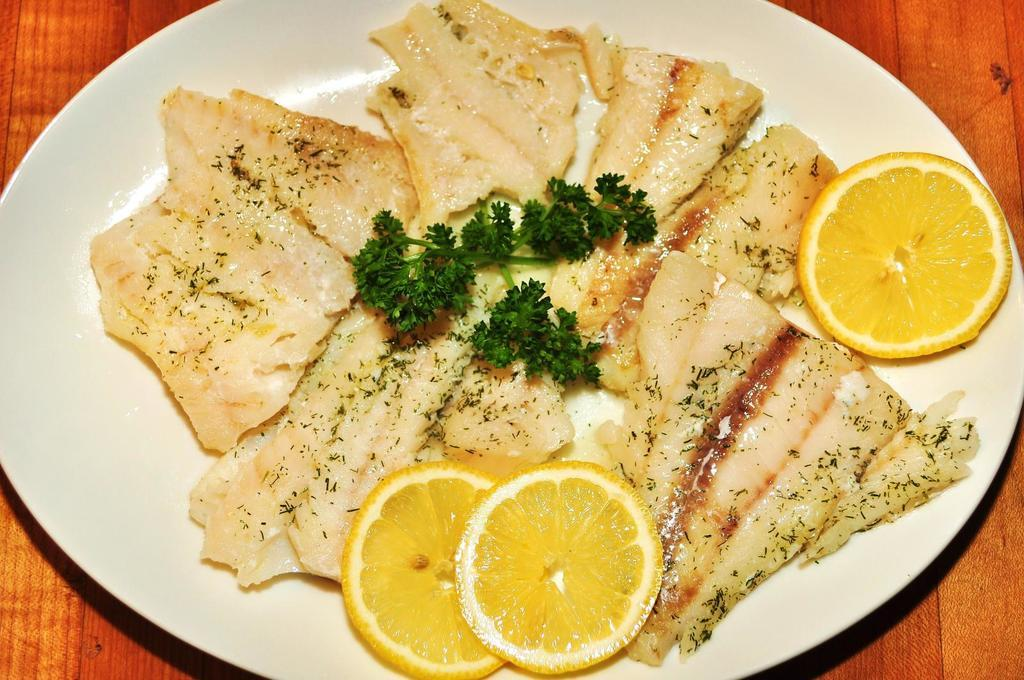What is on the plate in the image? There is a food item on a plate in the image. What is the plate resting on? The plate is on a wooden board. What type of linen is draped over the food item in the image? There is no linen present in the image; the food item is on a plate resting on a wooden board. 